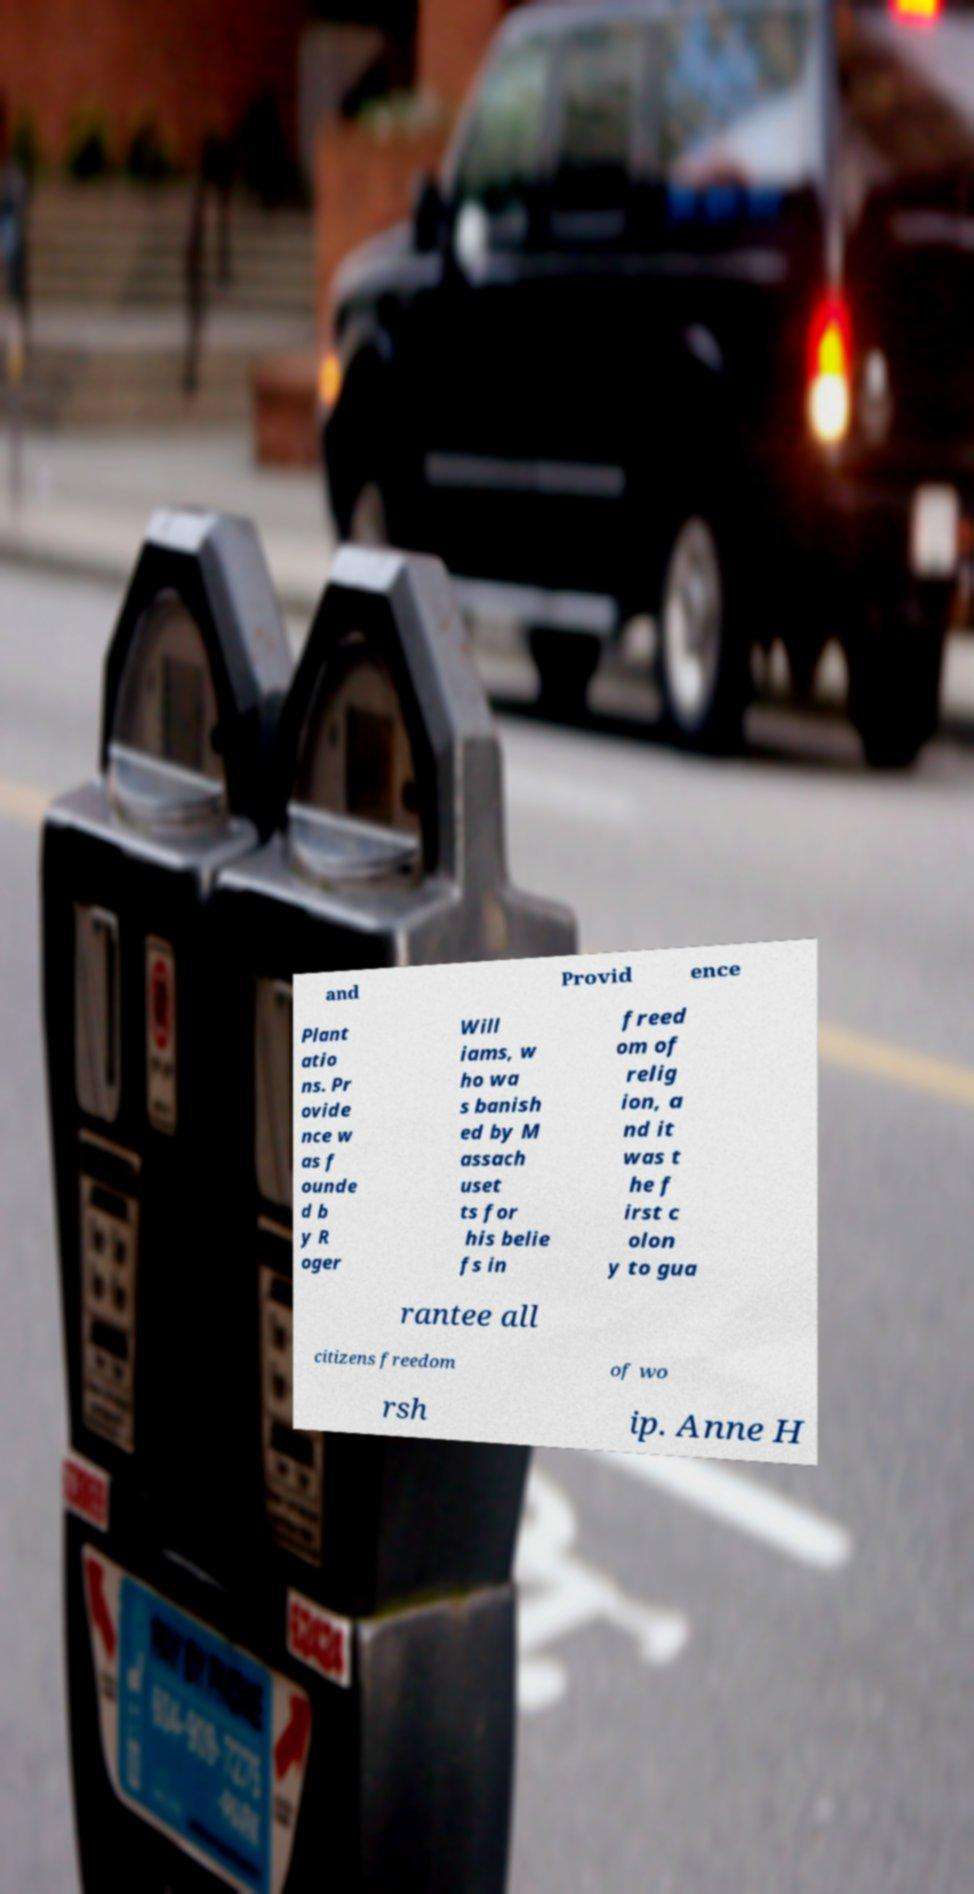There's text embedded in this image that I need extracted. Can you transcribe it verbatim? and Provid ence Plant atio ns. Pr ovide nce w as f ounde d b y R oger Will iams, w ho wa s banish ed by M assach uset ts for his belie fs in freed om of relig ion, a nd it was t he f irst c olon y to gua rantee all citizens freedom of wo rsh ip. Anne H 